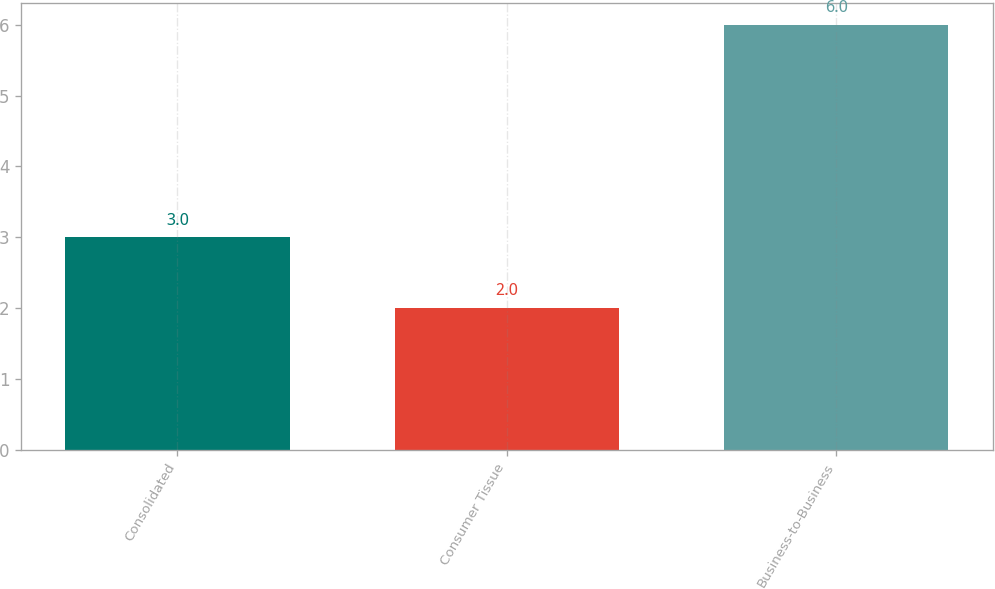Convert chart to OTSL. <chart><loc_0><loc_0><loc_500><loc_500><bar_chart><fcel>Consolidated<fcel>Consumer Tissue<fcel>Business-to-Business<nl><fcel>3<fcel>2<fcel>6<nl></chart> 